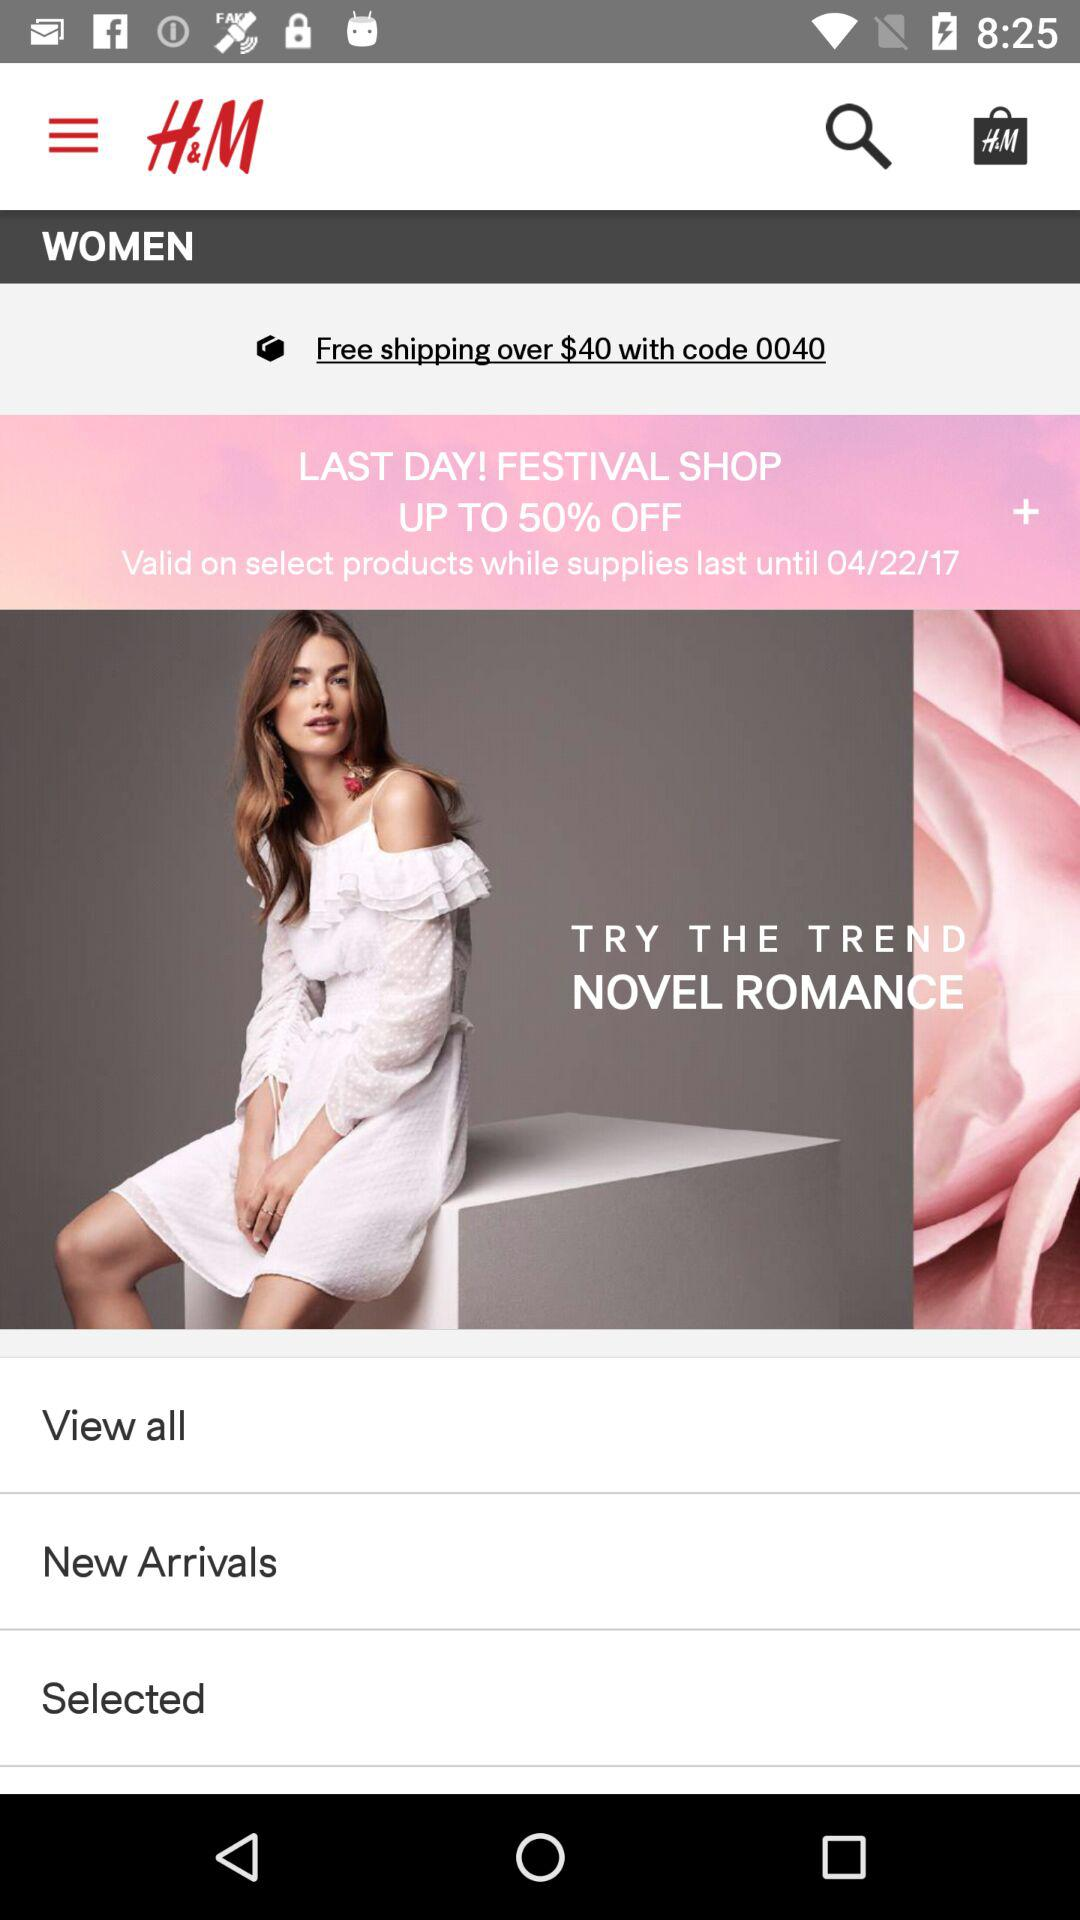How long is the product valid?
When the provided information is insufficient, respond with <no answer>. <no answer> 